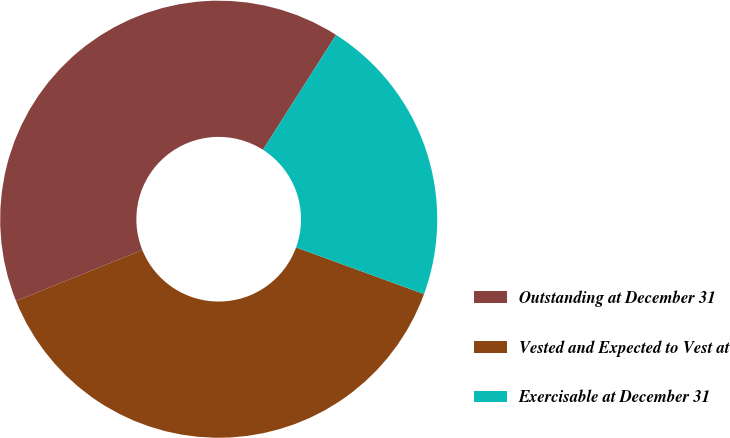<chart> <loc_0><loc_0><loc_500><loc_500><pie_chart><fcel>Outstanding at December 31<fcel>Vested and Expected to Vest at<fcel>Exercisable at December 31<nl><fcel>40.13%<fcel>38.33%<fcel>21.54%<nl></chart> 